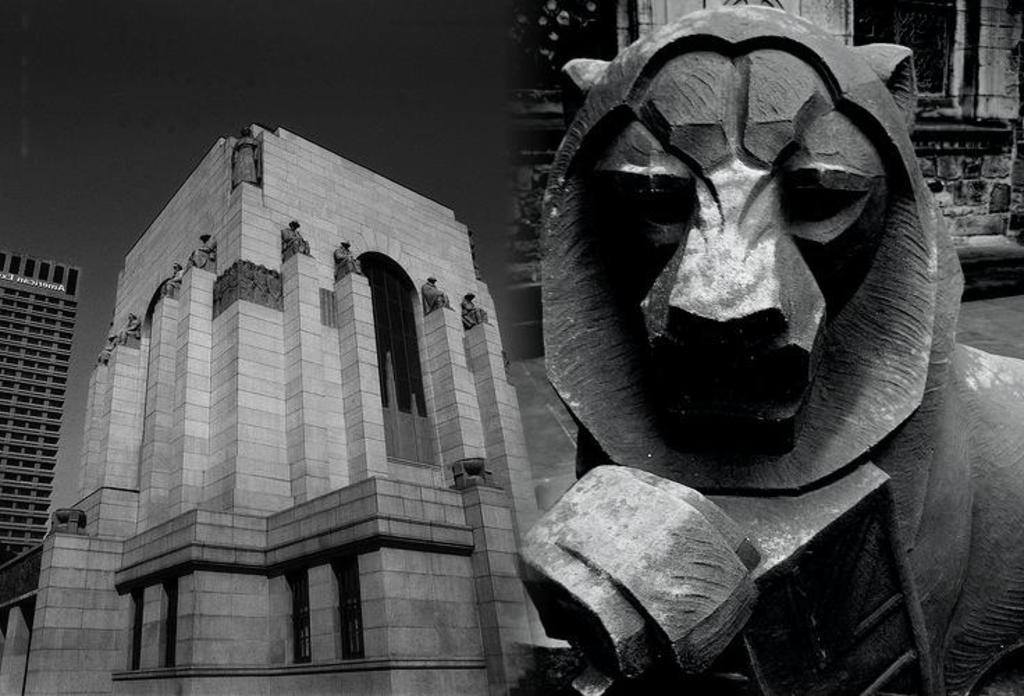How would you summarize this image in a sentence or two? In this image there are tall buildings. On the right side, we can see animal face sculpture. There is sky. 